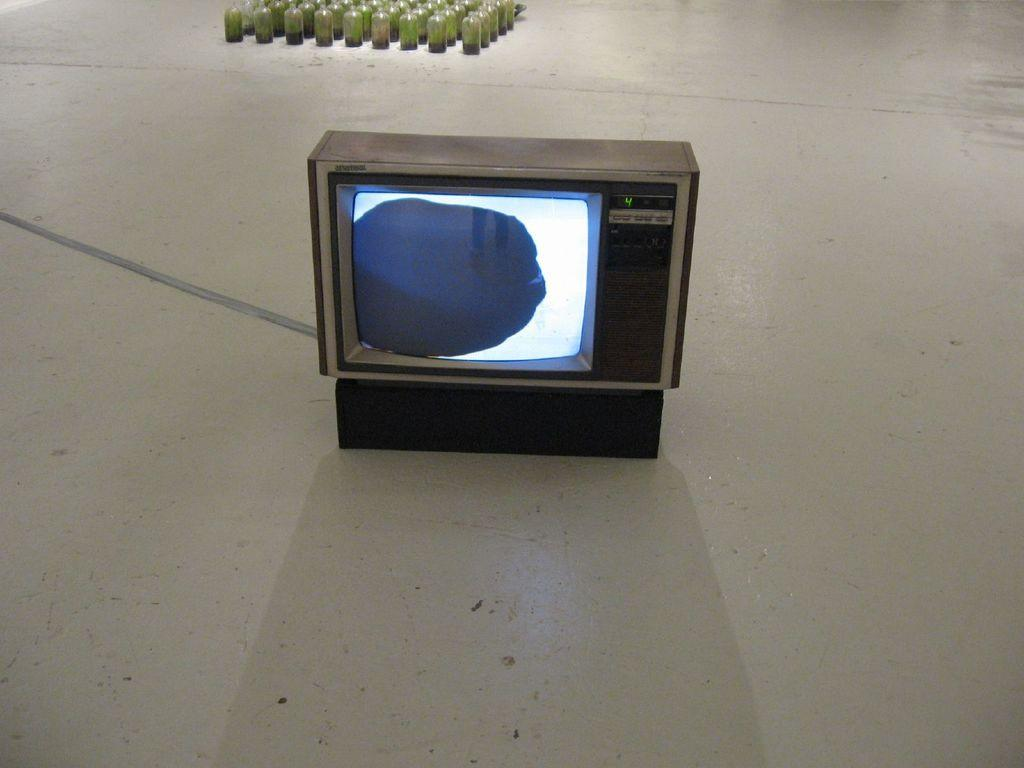Provide a one-sentence caption for the provided image. A small old school Tv is set to channel number four. 